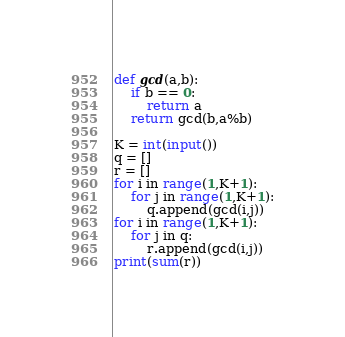<code> <loc_0><loc_0><loc_500><loc_500><_Python_>def gcd(a,b):
    if b == 0:
        return a
    return gcd(b,a%b)

K = int(input())
q = []
r = []
for i in range(1,K+1):
    for j in range(1,K+1):
        q.append(gcd(i,j))
for i in range(1,K+1):
    for j in q:
        r.append(gcd(i,j))
print(sum(r))</code> 